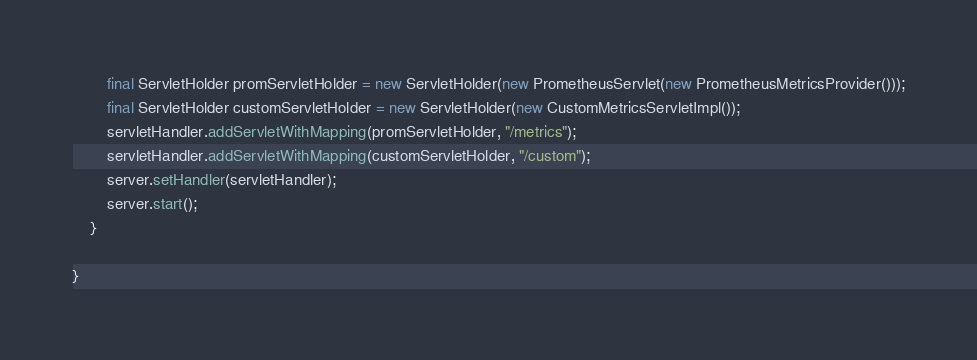<code> <loc_0><loc_0><loc_500><loc_500><_Java_>        final ServletHolder promServletHolder = new ServletHolder(new PrometheusServlet(new PrometheusMetricsProvider()));
        final ServletHolder customServletHolder = new ServletHolder(new CustomMetricsServletImpl());
        servletHandler.addServletWithMapping(promServletHolder, "/metrics");
        servletHandler.addServletWithMapping(customServletHolder, "/custom");
        server.setHandler(servletHandler);
        server.start();
    }

}
</code> 